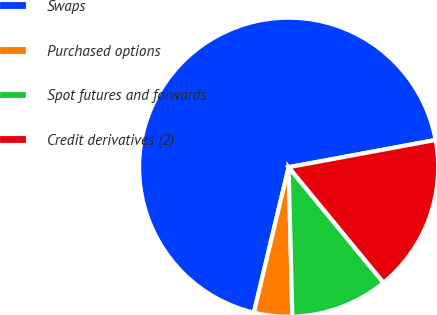Convert chart to OTSL. <chart><loc_0><loc_0><loc_500><loc_500><pie_chart><fcel>Swaps<fcel>Purchased options<fcel>Spot futures and forwards<fcel>Credit derivatives (2)<nl><fcel>68.35%<fcel>4.13%<fcel>10.55%<fcel>16.97%<nl></chart> 